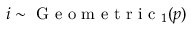Convert formula to latex. <formula><loc_0><loc_0><loc_500><loc_500>i \sim G e o m e t r i c _ { 1 } ( p )</formula> 